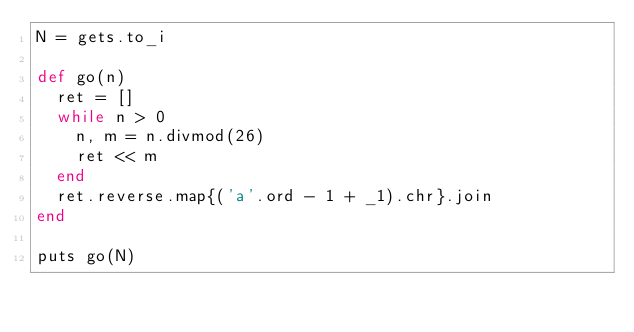<code> <loc_0><loc_0><loc_500><loc_500><_Ruby_>N = gets.to_i

def go(n)
  ret = []
  while n > 0
    n, m = n.divmod(26)
    ret << m
  end
  ret.reverse.map{('a'.ord - 1 + _1).chr}.join
end

puts go(N)</code> 